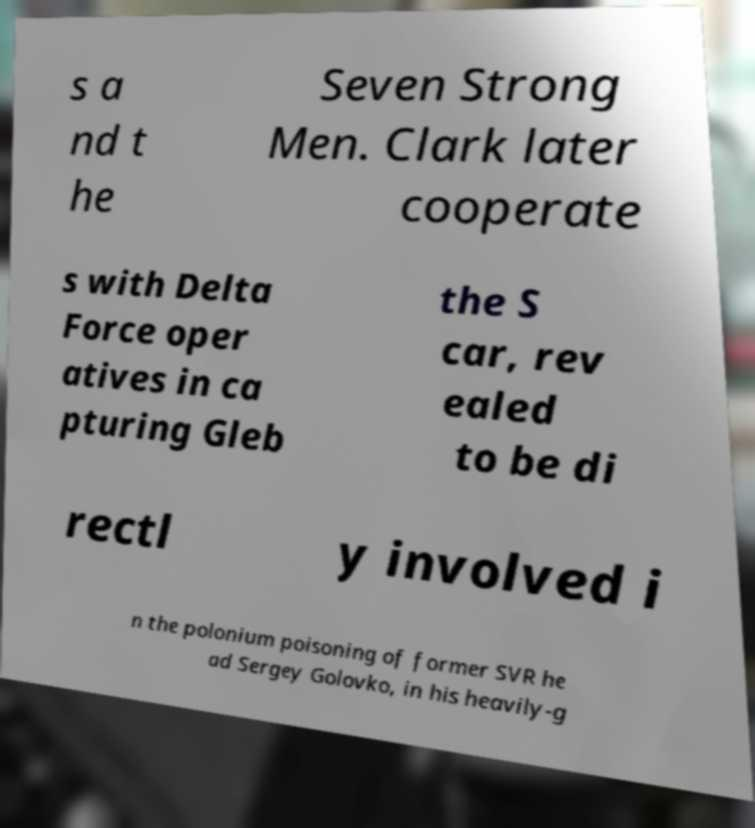Could you extract and type out the text from this image? s a nd t he Seven Strong Men. Clark later cooperate s with Delta Force oper atives in ca pturing Gleb the S car, rev ealed to be di rectl y involved i n the polonium poisoning of former SVR he ad Sergey Golovko, in his heavily-g 